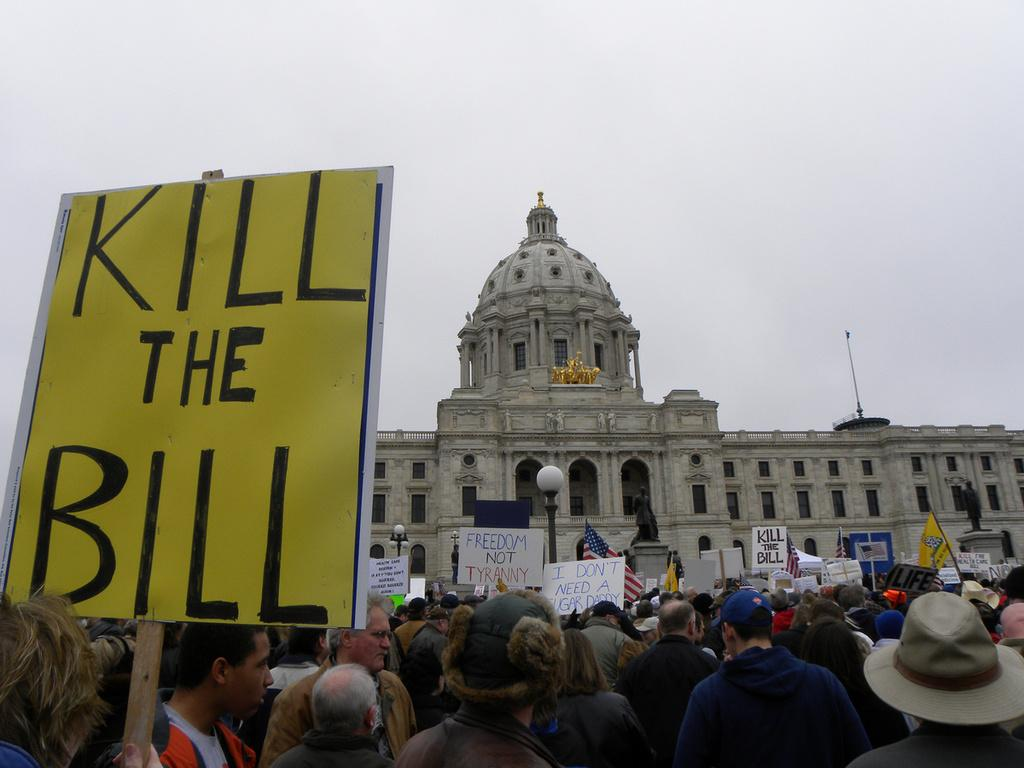What type of building can be seen in the background of the image? There is a building with a dome in the image. Where are the people located in the image? The people are standing on the road in the image. What are the people doing in the image? The people are participating in a protest. What are the protesters holding in their hands? The protesters are holding boards in their hands. What type of eggnog is being served at the school in the image? There is no mention of eggnog or a school in the image; it features a building with a dome and people protesting on the road. 